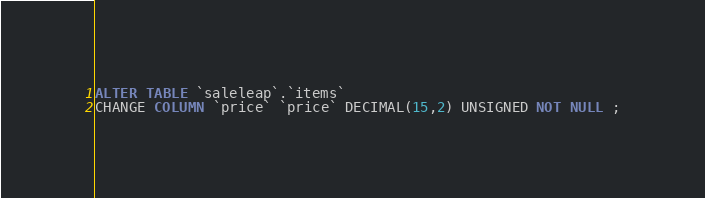Convert code to text. <code><loc_0><loc_0><loc_500><loc_500><_SQL_>ALTER TABLE `saleleap`.`items`
CHANGE COLUMN `price` `price` DECIMAL(15,2) UNSIGNED NOT NULL ;</code> 